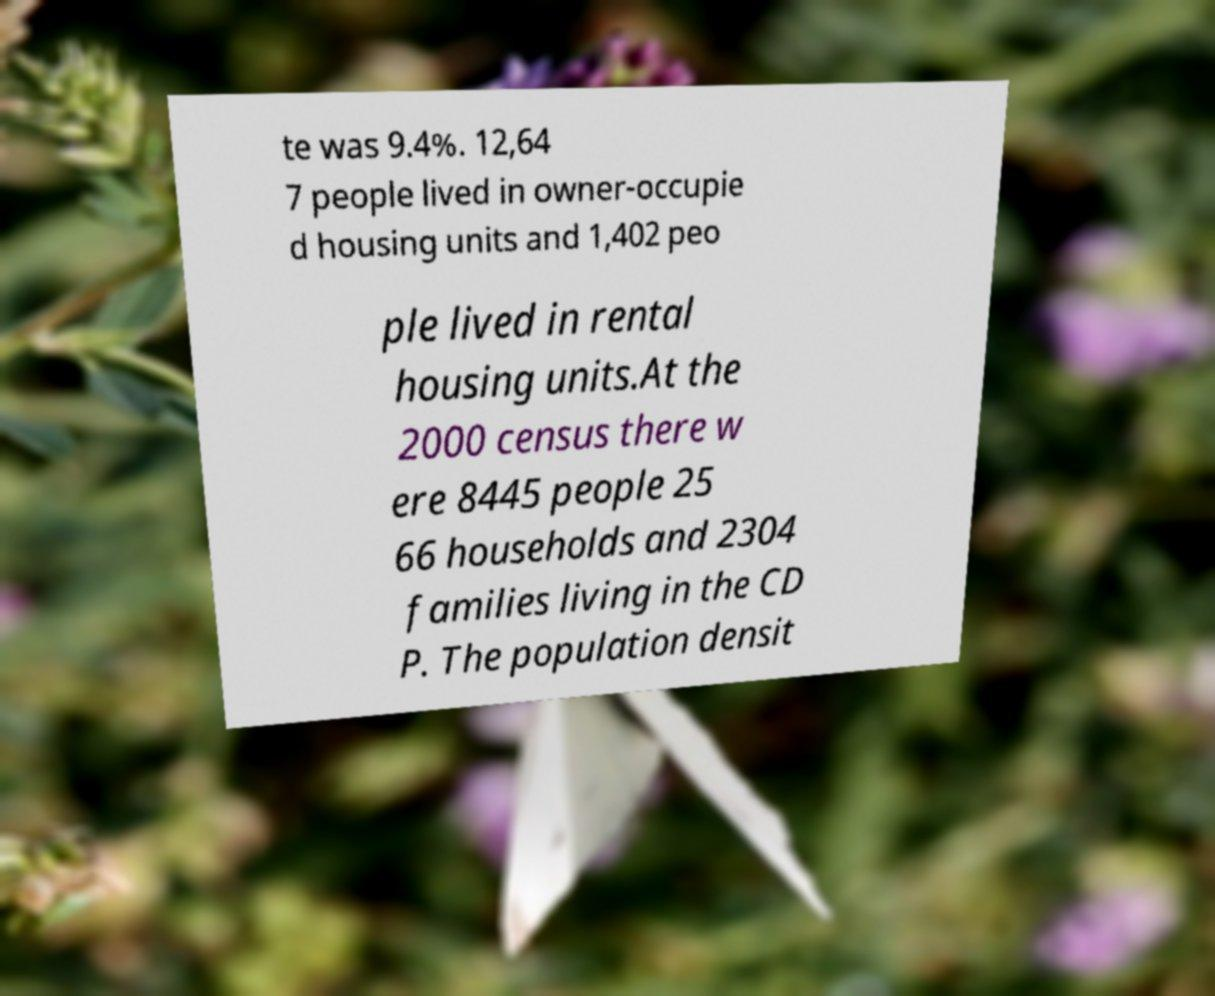Please identify and transcribe the text found in this image. te was 9.4%. 12,64 7 people lived in owner-occupie d housing units and 1,402 peo ple lived in rental housing units.At the 2000 census there w ere 8445 people 25 66 households and 2304 families living in the CD P. The population densit 